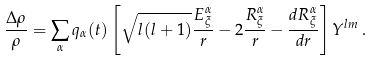<formula> <loc_0><loc_0><loc_500><loc_500>\frac { \Delta \rho } { \rho } = \sum _ { \alpha } q _ { \alpha } ( t ) \left [ \sqrt { l ( l + 1 ) } \frac { E _ { \xi } ^ { \alpha } } { r } - 2 \frac { R _ { \xi } ^ { \alpha } } { r } - \frac { d R _ { \xi } ^ { \alpha } } { d r } \right ] Y ^ { l m } \, .</formula> 